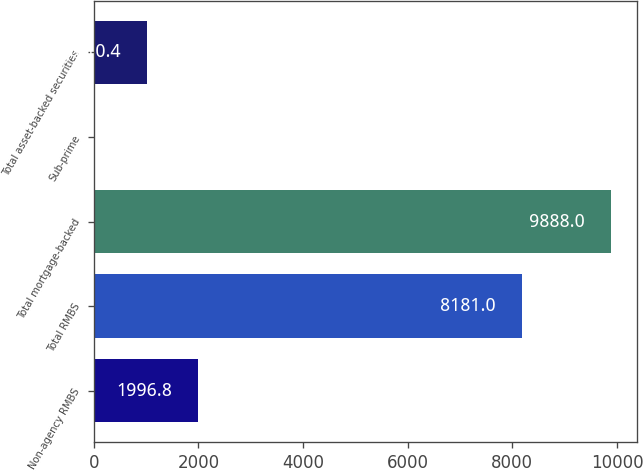Convert chart. <chart><loc_0><loc_0><loc_500><loc_500><bar_chart><fcel>Non-agency RMBS<fcel>Total RMBS<fcel>Total mortgage-backed<fcel>Sub-prime<fcel>Total asset-backed securities<nl><fcel>1996.8<fcel>8181<fcel>9888<fcel>24<fcel>1010.4<nl></chart> 